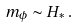<formula> <loc_0><loc_0><loc_500><loc_500>m _ { \phi } \sim H _ { * } \, .</formula> 